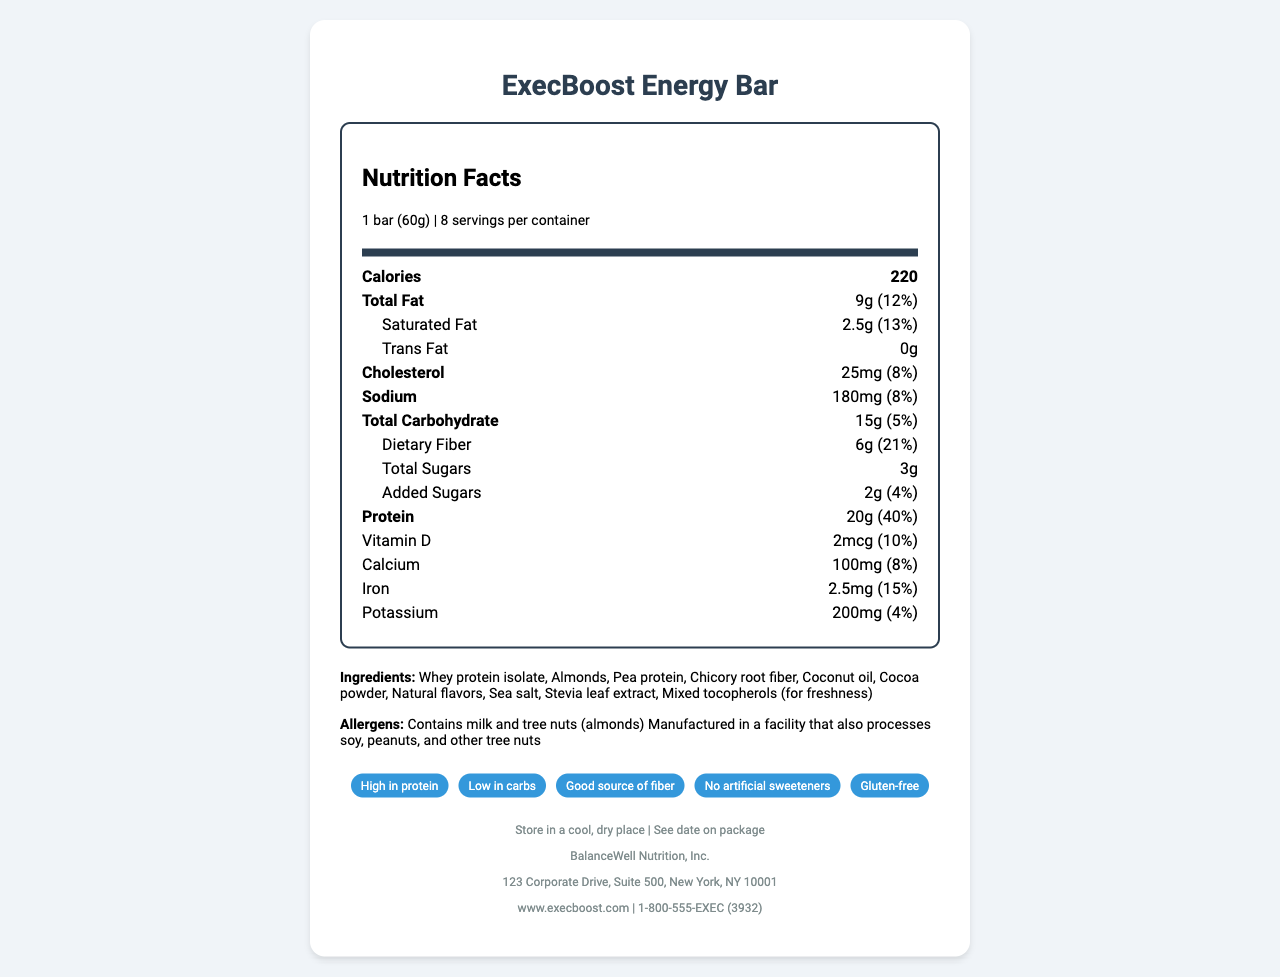what is the serving size of the ExecBoost Energy Bar? The serving size is clearly listed under the Nutrition Facts section as "1 bar (60g)".
Answer: 1 bar (60g) how many calories are in one serving of the ExecBoost Energy Bar? The number of calories per serving is listed as 220 in the Nutrition Facts section.
Answer: 220 what is the total fat content per serving, and what percentage of the daily value does it represent? The total fat content is stated as 9g, which represents 12% of the daily value.
Answer: 9g, 12% what are the top three ingredients in the ExecBoost Energy Bar? The top three ingredients listed are Whey protein isolate, Almonds, and Pea protein.
Answer: Whey protein isolate, Almonds, Pea protein how much protein does one serving of the ExecBoost Energy Bar provide? The protein content per serving is 20g, as noted in the Nutrition Facts section.
Answer: 20g which of the following claims is not made about the ExecBoost Energy Bar? A. High in protein B. Contains artificial sweeteners C. Gluten-free D. Good source of fiber The document claims "No artificial sweeteners," so option B is not a claim made about the bar.
Answer: B according to the document, what two allergens does the ExecBoost Energy Bar contain? A. Peanuts and milk B. Almonds and soy C. Milk and almonds D. Peanuts and soy The bar contains milk and almonds, as stated under the allergens section.
Answer: C is the ExecBoost Energy Bar suitable for someone who is avoiding gluten? The document explicitly claims that the bar is "Gluten-free."
Answer: Yes where should the ExecBoost Energy Bar be stored? The storage instructions specify to store the bar in a cool, dry place.
Answer: Store in a cool, dry place would you recommend the ExecBoost Energy Bar for someone looking to increase their dietary fiber intake? The bar provides 6g of dietary fiber per serving, accounting for 21% of the daily value, making it a good source of fiber.
Answer: Yes summarize the main nutritional benefits and claims of the ExecBoost Energy Bar. The bar offers 20g of protein and 6g of dietary fiber per serving, being low in carbs and free from gluten and artificial sweeteners. It also includes vitamins and minerals like vitamin D, calcium, iron, and potassium, making it suitable for busy executives.
Answer: The ExecBoost Energy Bar is high in protein (20g per serving), low in carbs, and a good source of fiber (6g per serving). It contains no artificial sweeteners, is gluten-free, and provides essential vitamins and minerals. what is the exact address of the manufacturer of the ExecBoost Energy Bar? The address provided in the footer is 123 Corporate Drive, Suite 500, New York, NY 10001.
Answer: 123 Corporate Drive, Suite 500, New York, NY 10001 how much sodium does the ExecBoost Energy Bar contain? The sodium content per serving is 180mg, as stated in the Nutrition Facts section.
Answer: 180mg what is the cholesterol content per serving, and how much does it contribute to the daily value percentage? Each serving contains 25mg of cholesterol, contributing 8% to the daily value.
Answer: 25mg, 8% how much added sugars are there in one serving of the bar, and what percentage of the daily value does it account for? The amount of added sugars per serving is 2g, which is 4% of the daily value.
Answer: 2g, 4% who is the manufacturer of ExecBoost Energy Bar? The manufacturer mentioned is BalanceWell Nutrition, Inc., as stated in the footer.
Answer: BalanceWell Nutrition, Inc. what type of plant-based protein is included in the ExecBoost Energy Bar? Among the ingredients, pea protein is listed as the plant-based protein.
Answer: Pea protein where is the best before date of the ExecBoost Energy Bar specified? The document instructs to see the date on the package for the best before date.
Answer: See date on package how much potassium does one serving of the ExecBoost Energy Bar provide? The potassium content per serving is listed as 200mg.
Answer: 200mg how much iron does the ExecBoost Energy Bar have in each serving? Each serving contains 2.5mg of iron.
Answer: 2.5mg does the ExecBoost Energy Bar contain artificial sweeteners? The document claims that the bar contains no artificial sweeteners.
Answer: No what is the primary type of fat used in the ExecBoost Energy Bar? The ingredient list includes coconut oil as the primary fat source.
Answer: Coconut oil is the ExecBoost Energy Bar suitable for vegetarians? The document does not provide enough information to determine if the bar is suitable for vegetarians, as it does not specify whether the whey protein isolate is sourced in a vegetarian manner.
Answer: Cannot be determined how do you contact customer service for ExecBoost Energy Bar? The customer service contact number is 1-800-555-EXEC (3932), as listed in the footer.
Answer: 1-800-555-EXEC (3932) how many servings are there per container of ExecBoost Energy Bar? The container holds 8 servings, as stated in the Nutrition Facts section.
Answer: 8 what is the total carbohydrate content per serving, and what is the daily value percentage? The total carbohydrate content per serving is 15g, making up 5% of the daily value.
Answer: 15g, 5% 